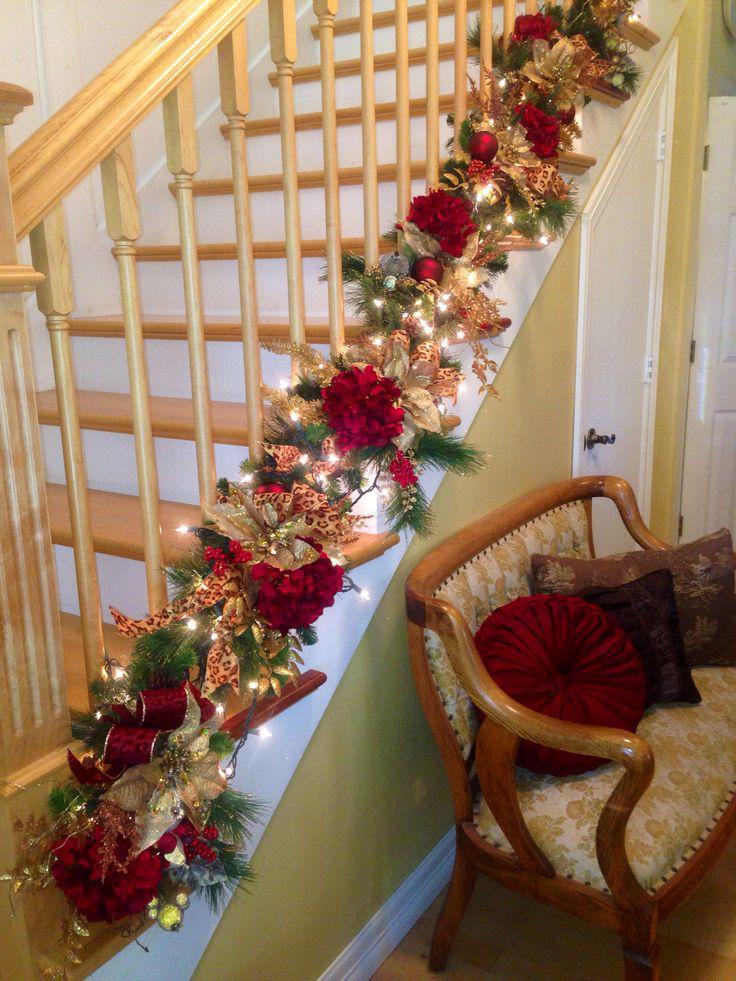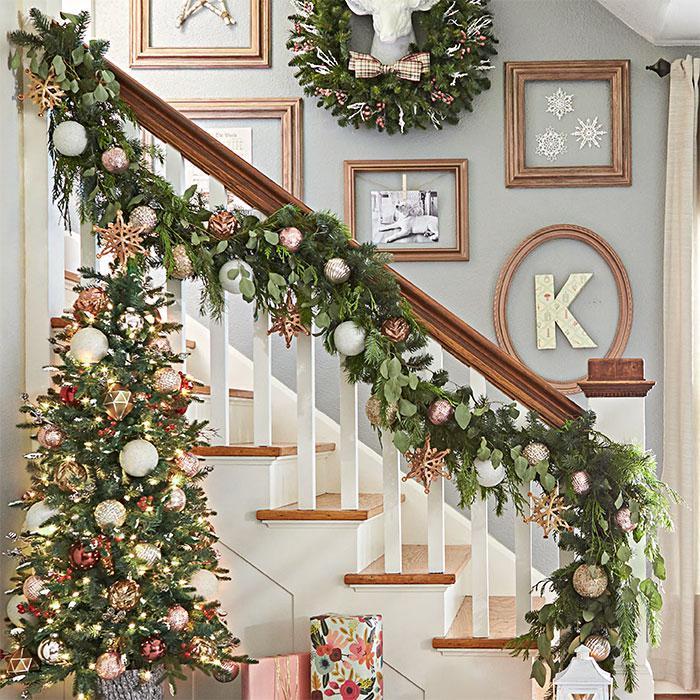The first image is the image on the left, the second image is the image on the right. Considering the images on both sides, is "One image shows a staircase with white bars and a brown handrail that descends diagnonally to the right and has an evergreen tree beside it." valid? Answer yes or no. Yes. The first image is the image on the left, the second image is the image on the right. Assess this claim about the two images: "There are no visible windows within any of these rooms.". Correct or not? Answer yes or no. Yes. 